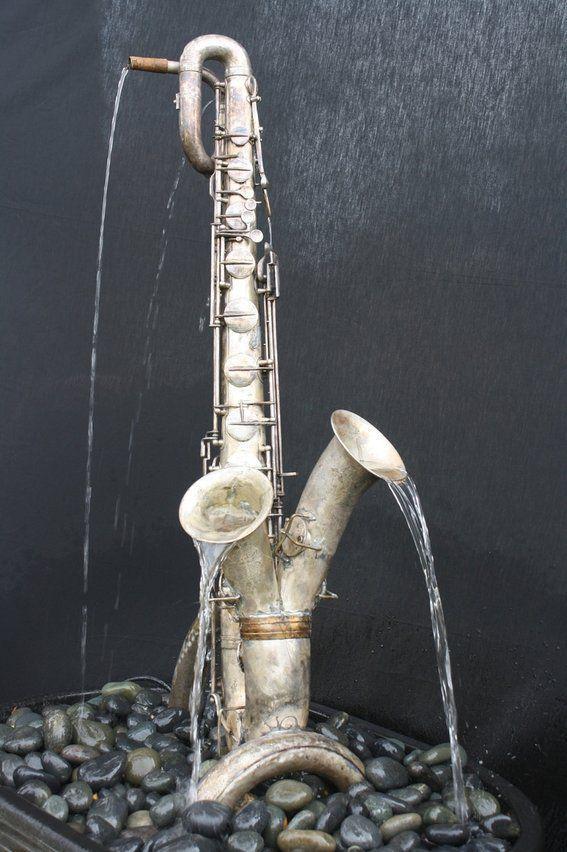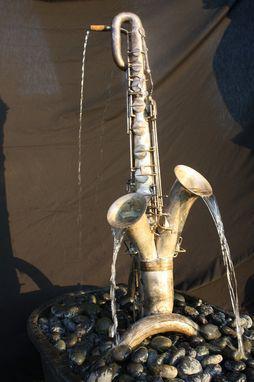The first image is the image on the left, the second image is the image on the right. For the images displayed, is the sentence "At least one sax has water coming out of it." factually correct? Answer yes or no. Yes. The first image is the image on the left, the second image is the image on the right. For the images displayed, is the sentence "In one or more if the images a musical instrument has been converted to function as a water fountain." factually correct? Answer yes or no. Yes. 